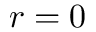<formula> <loc_0><loc_0><loc_500><loc_500>r = 0</formula> 